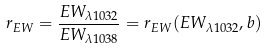Convert formula to latex. <formula><loc_0><loc_0><loc_500><loc_500>r _ { E W } = \frac { E W _ { \lambda 1 0 3 2 \AA } } { E W _ { \lambda 1 0 3 8 \AA } } = r _ { E W } ( E W _ { \lambda 1 0 3 2 \AA } , b )</formula> 